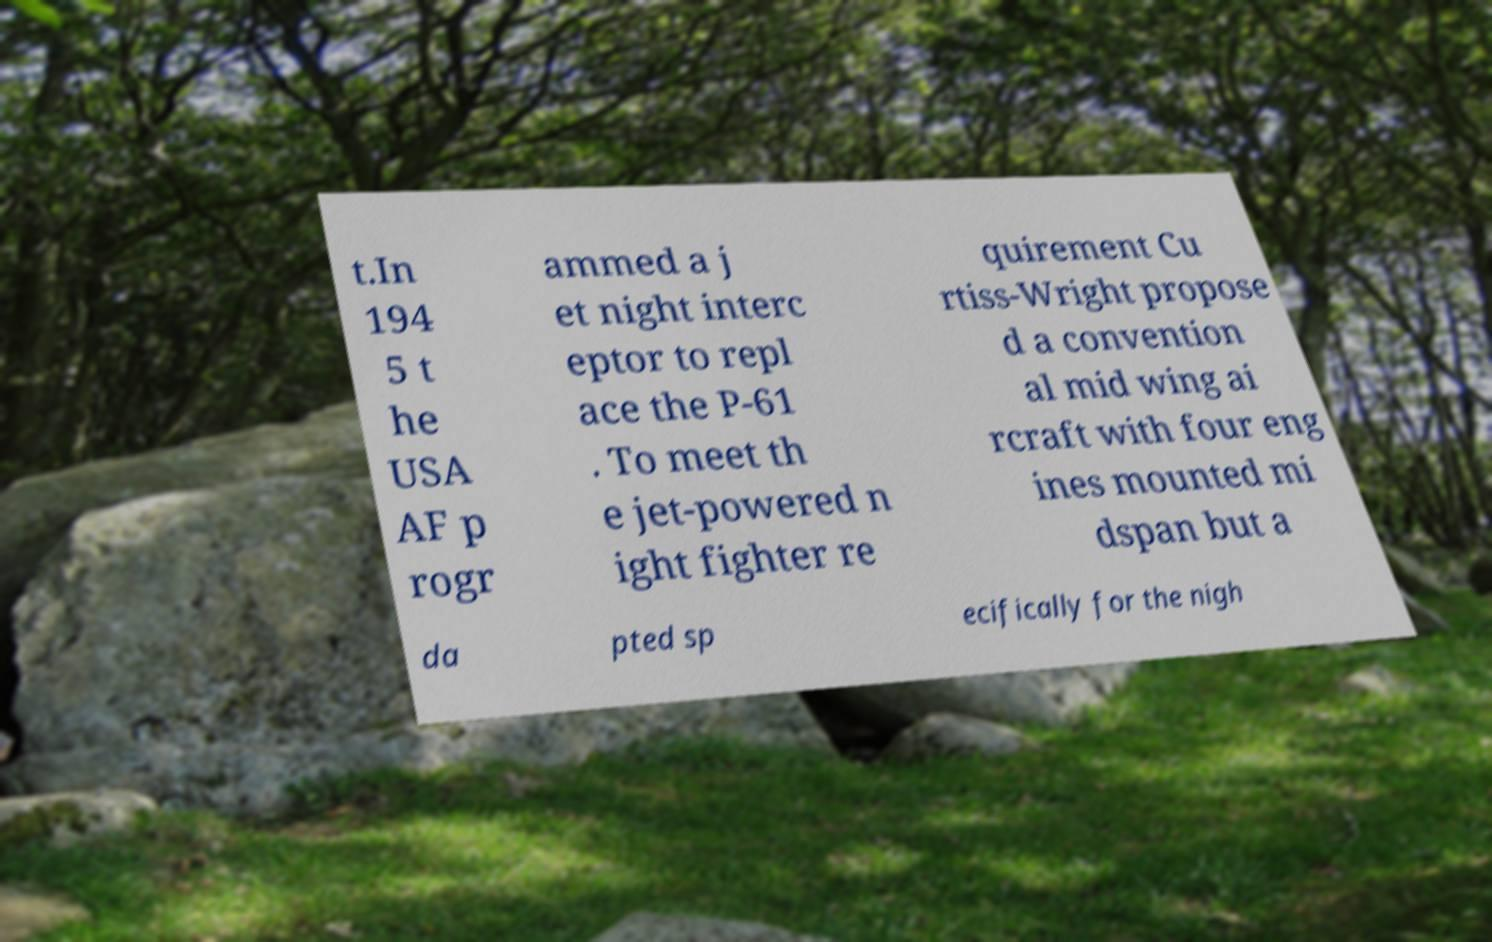Can you read and provide the text displayed in the image?This photo seems to have some interesting text. Can you extract and type it out for me? t.In 194 5 t he USA AF p rogr ammed a j et night interc eptor to repl ace the P-61 . To meet th e jet-powered n ight fighter re quirement Cu rtiss-Wright propose d a convention al mid wing ai rcraft with four eng ines mounted mi dspan but a da pted sp ecifically for the nigh 